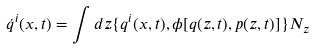<formula> <loc_0><loc_0><loc_500><loc_500>\dot { q } ^ { i } ( x , t ) = \int d z \{ q ^ { i } ( x , t ) , \phi [ q ( z , t ) , p ( z , t ) ] \} N _ { z }</formula> 